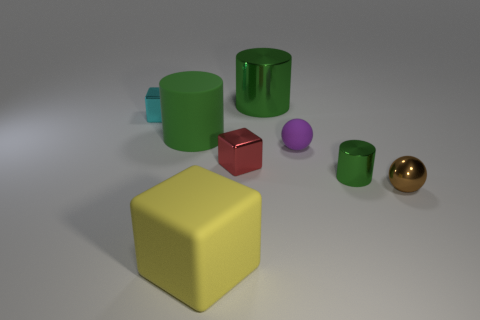Add 1 rubber blocks. How many objects exist? 9 Subtract all small cyan blocks. How many blocks are left? 2 Subtract all cylinders. How many objects are left? 5 Subtract 0 purple cylinders. How many objects are left? 8 Subtract all rubber balls. Subtract all purple objects. How many objects are left? 6 Add 7 shiny balls. How many shiny balls are left? 8 Add 8 large yellow cubes. How many large yellow cubes exist? 9 